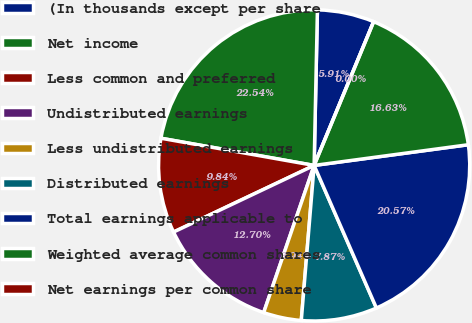Convert chart to OTSL. <chart><loc_0><loc_0><loc_500><loc_500><pie_chart><fcel>(In thousands except per share<fcel>Net income<fcel>Less common and preferred<fcel>Undistributed earnings<fcel>Less undistributed earnings<fcel>Distributed earnings<fcel>Total earnings applicable to<fcel>Weighted average common shares<fcel>Net earnings per common share<nl><fcel>5.91%<fcel>22.54%<fcel>9.84%<fcel>12.7%<fcel>3.94%<fcel>7.87%<fcel>20.57%<fcel>16.63%<fcel>0.0%<nl></chart> 